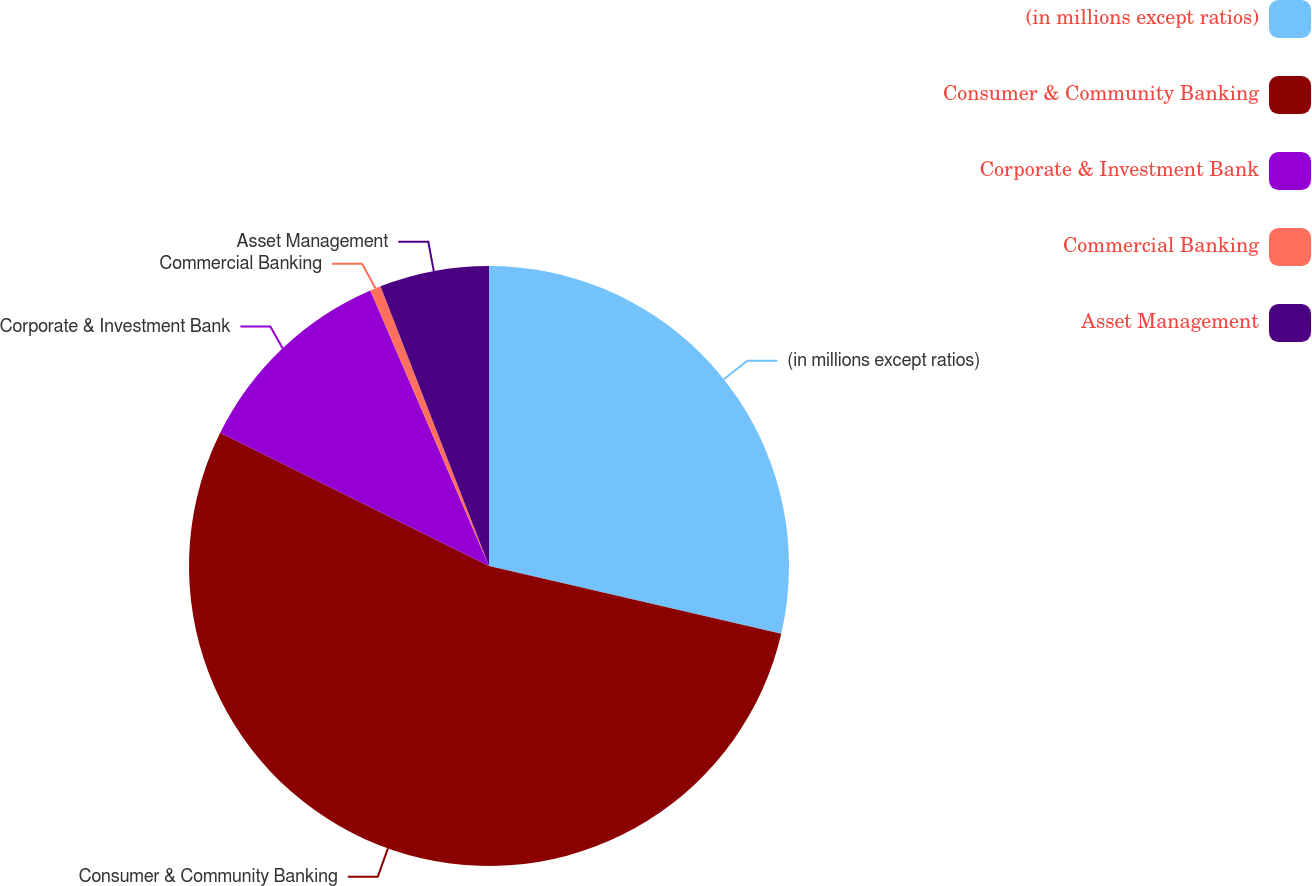Convert chart to OTSL. <chart><loc_0><loc_0><loc_500><loc_500><pie_chart><fcel>(in millions except ratios)<fcel>Consumer & Community Banking<fcel>Corporate & Investment Bank<fcel>Commercial Banking<fcel>Asset Management<nl><fcel>28.62%<fcel>53.69%<fcel>11.21%<fcel>0.58%<fcel>5.89%<nl></chart> 